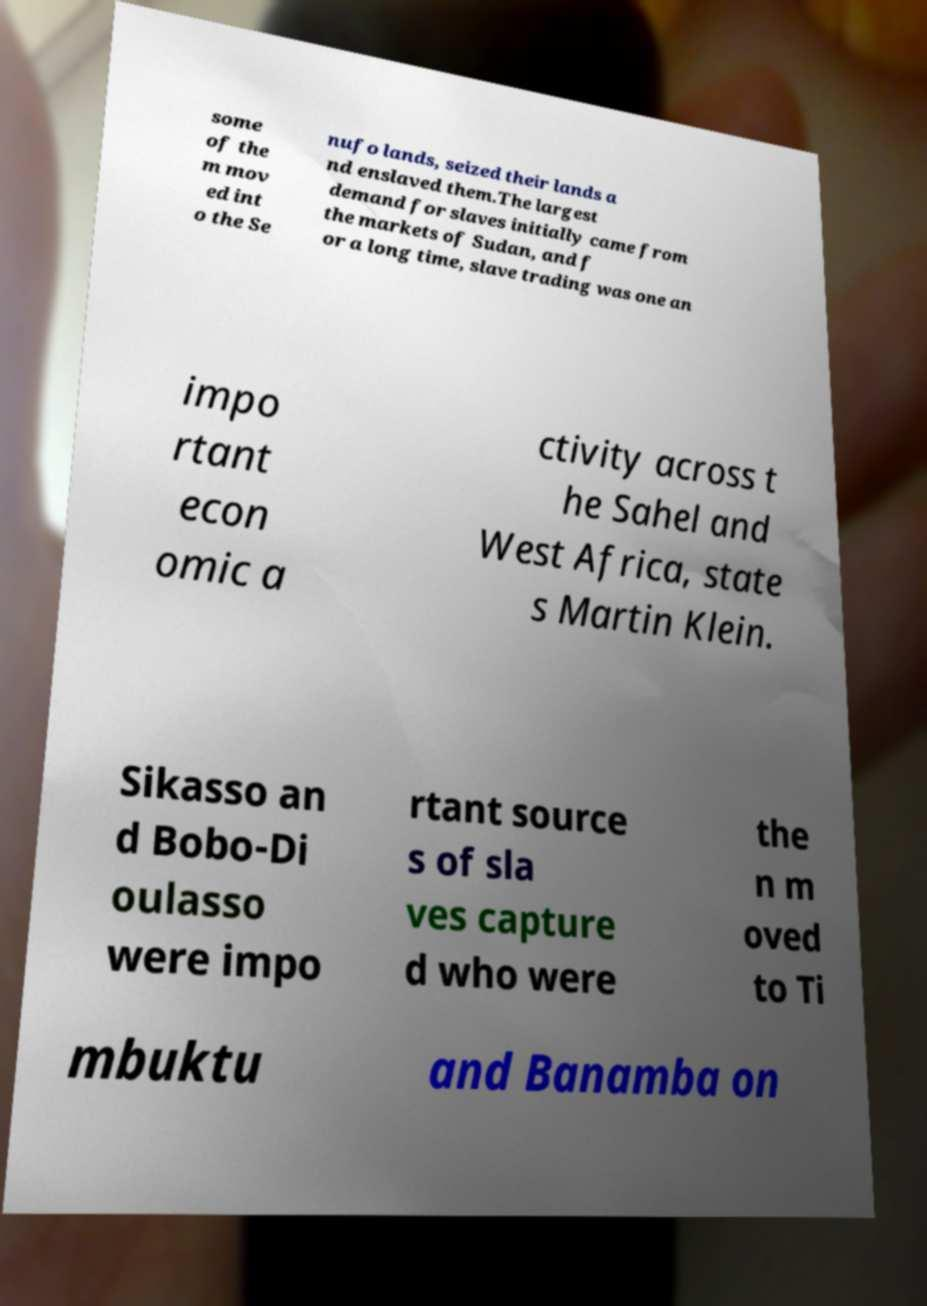Can you read and provide the text displayed in the image?This photo seems to have some interesting text. Can you extract and type it out for me? some of the m mov ed int o the Se nufo lands, seized their lands a nd enslaved them.The largest demand for slaves initially came from the markets of Sudan, and f or a long time, slave trading was one an impo rtant econ omic a ctivity across t he Sahel and West Africa, state s Martin Klein. Sikasso an d Bobo-Di oulasso were impo rtant source s of sla ves capture d who were the n m oved to Ti mbuktu and Banamba on 